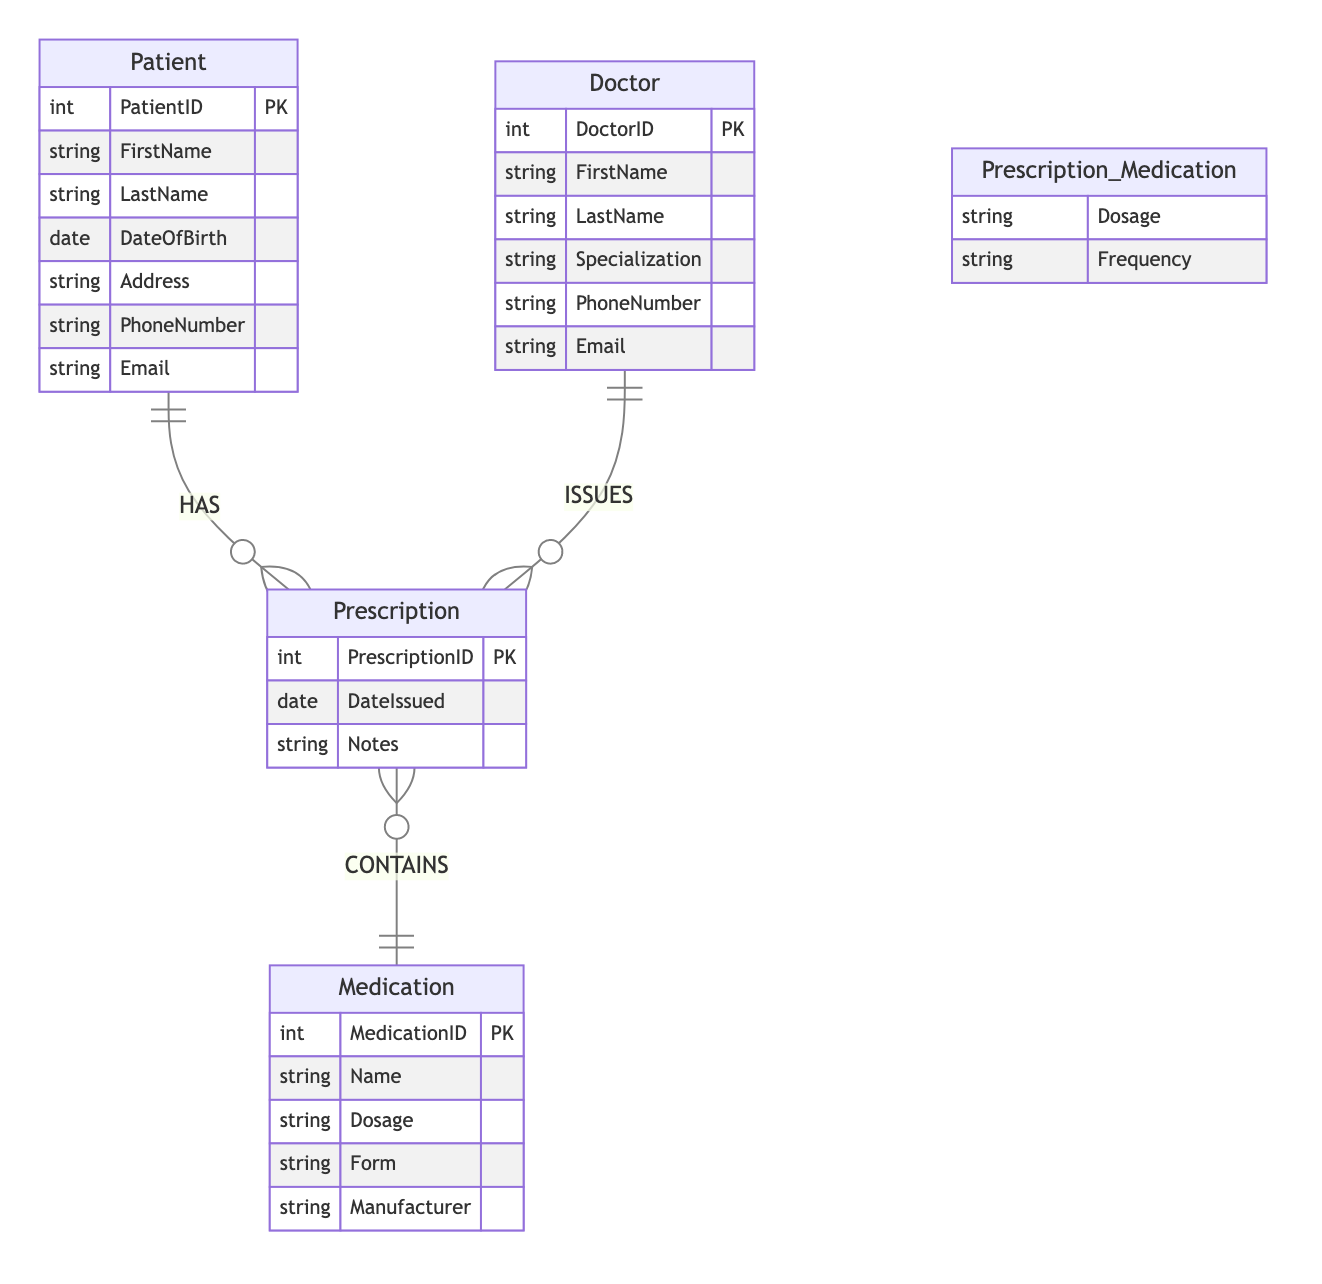What is the primary key of the Patient entity? The primary key (PK) is a unique identifier for the Patient entity, which is denoted as PatientID.
Answer: PatientID How many entities are represented in the diagram? The diagram contains four entities: Patient, Doctor, Prescription, and Medication. By counting them, we find there are four in total.
Answer: 4 What relationship connects Patient and Prescription? The connection between Patient and Prescription is a HAS relationship, indicating that a patient can have multiple prescriptions.
Answer: HAS Which entity issues prescriptions? The entity that issues prescriptions is the Doctor, as indicated by the ISSUES relationship that connects Doctor to Prescription.
Answer: Doctor What attributes are included in the Prescription entity? The Prescription entity includes the following attributes: PrescriptionID, DateIssued, and Notes.
Answer: PrescriptionID, DateIssued, Notes What does the Prescription entity contain from the Medication entity? The Prescription contains Dosage and Frequency from the Medication entity, as detailed in the CONTINUES relationship.
Answer: Dosage, Frequency How many relationships are shown in the diagram? There are three relationships depicted in the diagram: HAS, ISSUES, and CONTAINS. Counting them gives a total of three relationships.
Answer: 3 What is the primary key of the Medication entity? The primary key (PK) for the Medication entity is indicated as MedicationID, which uniquely identifies each medication.
Answer: MedicationID What type of relationship exists between Doctor and Prescription? The relationship between Doctor and Prescription is an ISSUES type, indicating that doctors are responsible for issuing prescriptions.
Answer: ISSUES Which entity contains information about medication dosage? The Prescription entity contains information about medication dosage, as it holds attributes related to the dosage of medications in the context of prescriptions.
Answer: Prescription 